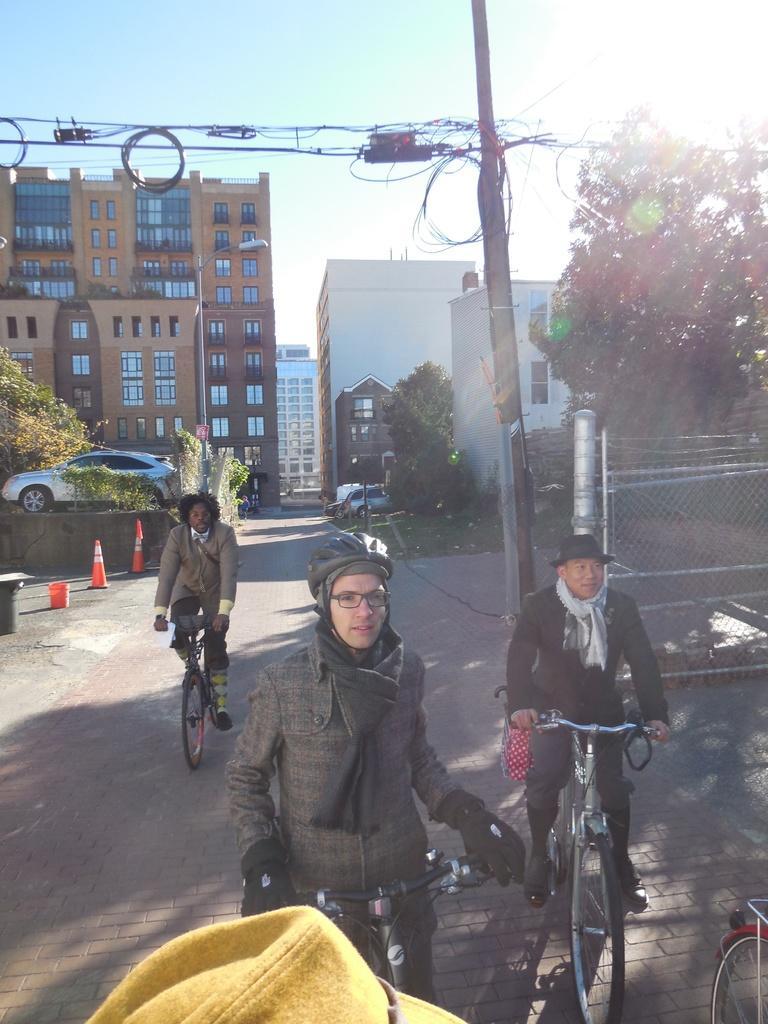How would you summarize this image in a sentence or two? In this picture there is a man holding a bicycle. There is also another man who is sitting on bicycle. There is a person who is riding a bicycle. There is a traffic cone, bucket, car, tree, buildings, plant and a pole at the background. 